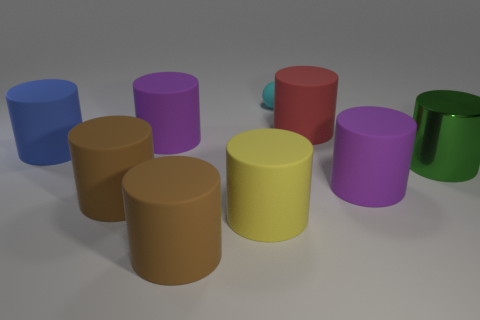Subtract 2 cylinders. How many cylinders are left? 6 Subtract all big green metallic cylinders. How many cylinders are left? 7 Subtract all brown cylinders. How many cylinders are left? 6 Subtract all brown cylinders. Subtract all red blocks. How many cylinders are left? 6 Add 1 cyan cylinders. How many objects exist? 10 Subtract all spheres. How many objects are left? 8 Add 1 green matte blocks. How many green matte blocks exist? 1 Subtract 0 green balls. How many objects are left? 9 Subtract all big yellow shiny cylinders. Subtract all big purple matte cylinders. How many objects are left? 7 Add 5 large blue rubber cylinders. How many large blue rubber cylinders are left? 6 